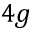Convert formula to latex. <formula><loc_0><loc_0><loc_500><loc_500>{ 4 g }</formula> 